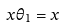<formula> <loc_0><loc_0><loc_500><loc_500>x \theta _ { 1 } = x</formula> 